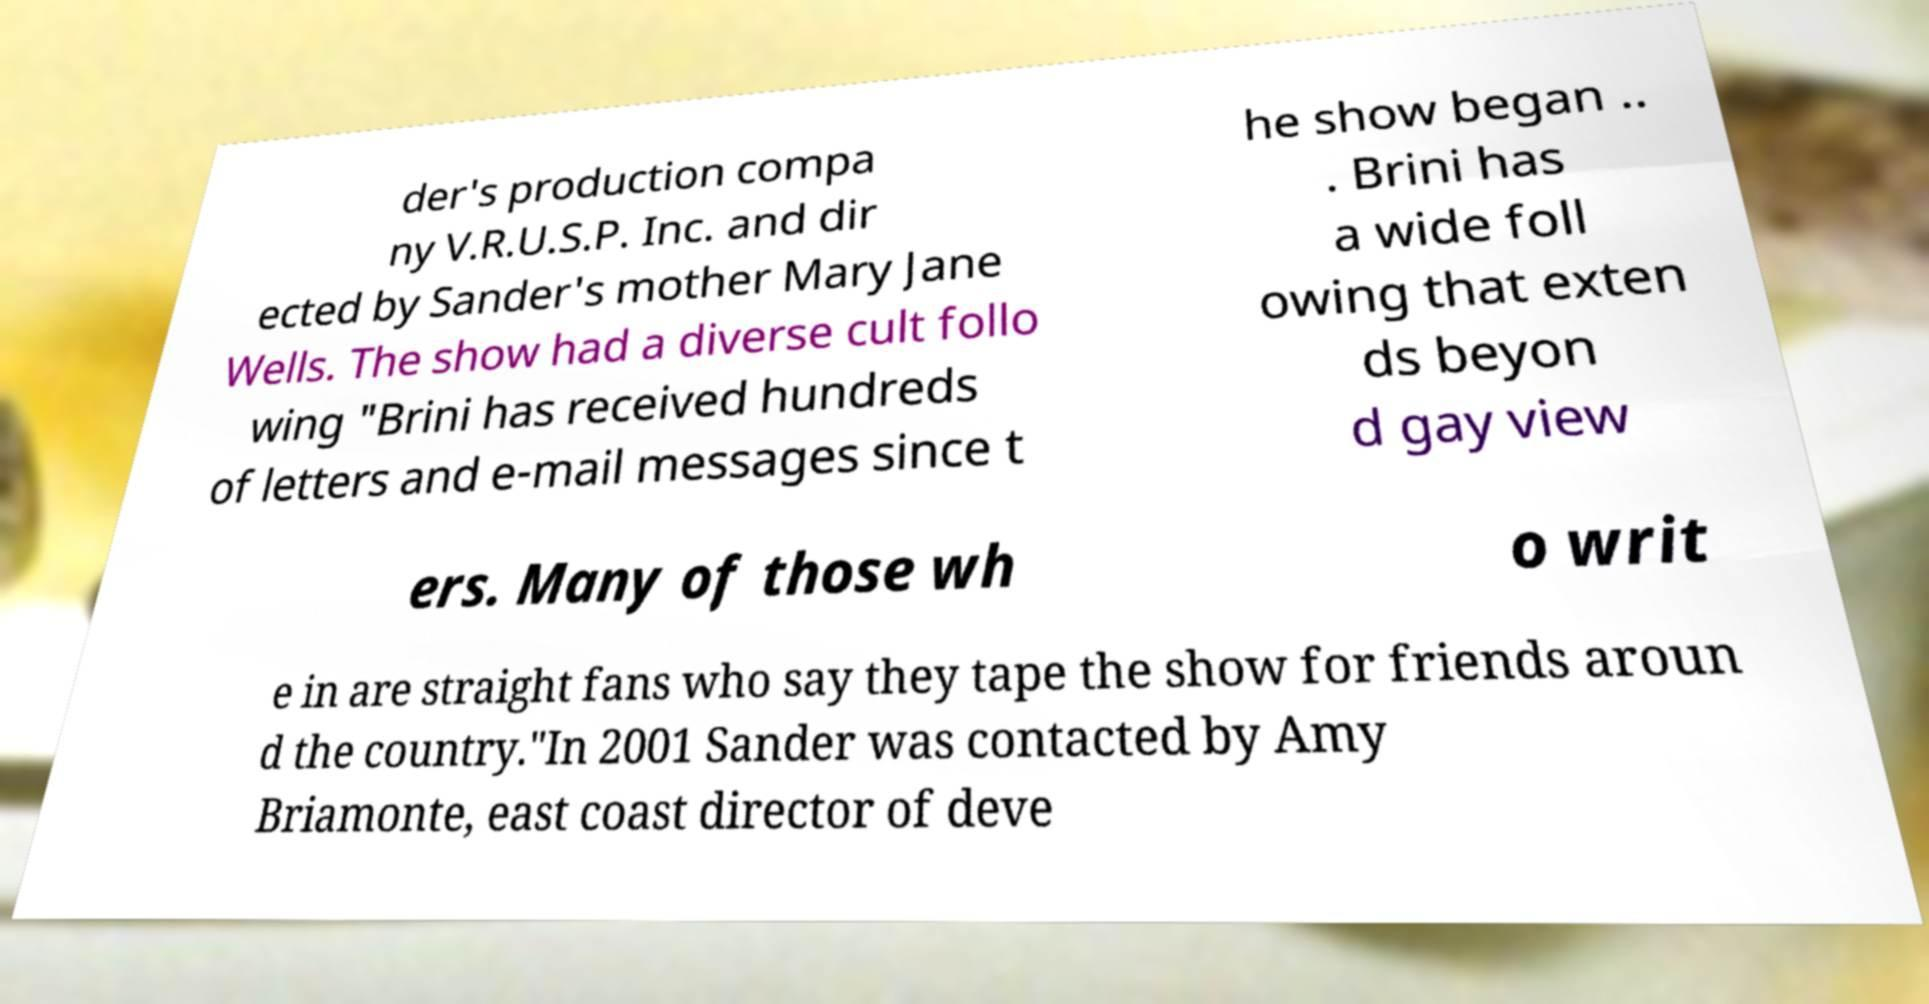Please read and relay the text visible in this image. What does it say? der's production compa ny V.R.U.S.P. Inc. and dir ected by Sander's mother Mary Jane Wells. The show had a diverse cult follo wing "Brini has received hundreds of letters and e-mail messages since t he show began .. . Brini has a wide foll owing that exten ds beyon d gay view ers. Many of those wh o writ e in are straight fans who say they tape the show for friends aroun d the country."In 2001 Sander was contacted by Amy Briamonte, east coast director of deve 